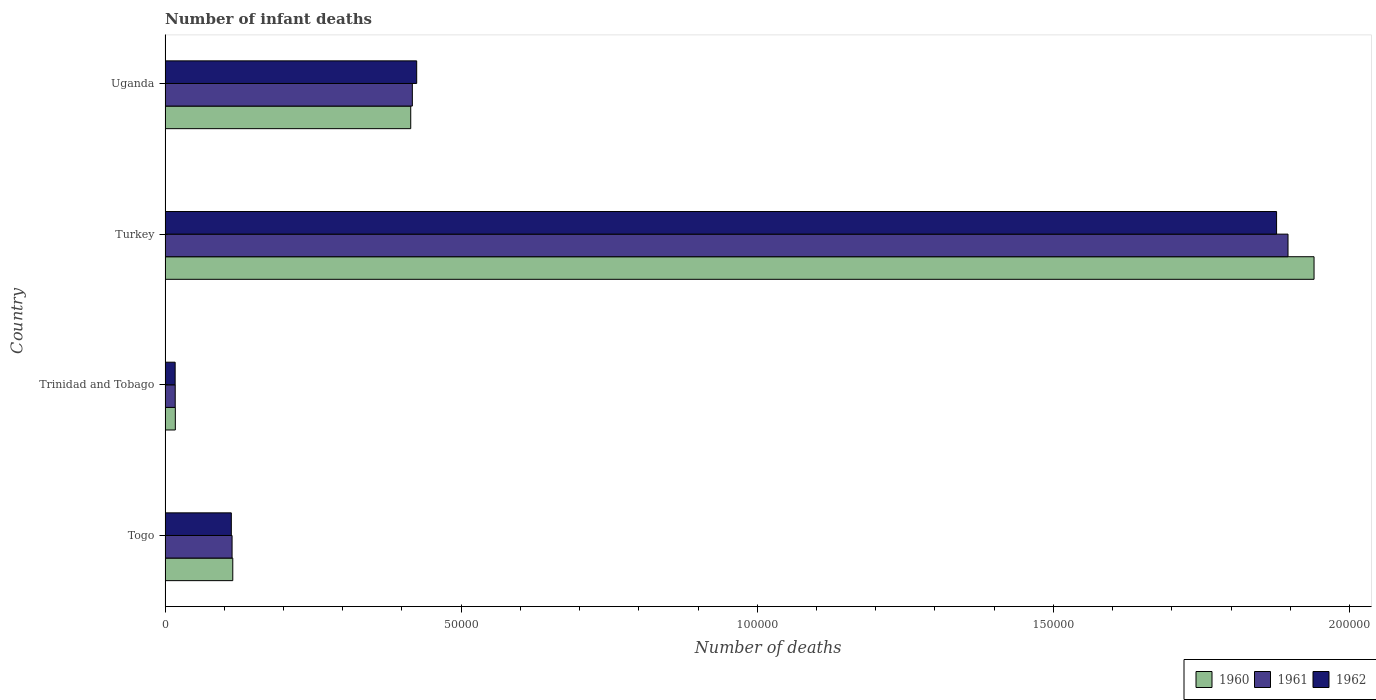How many different coloured bars are there?
Provide a succinct answer. 3. How many groups of bars are there?
Keep it short and to the point. 4. What is the label of the 3rd group of bars from the top?
Provide a succinct answer. Trinidad and Tobago. In how many cases, is the number of bars for a given country not equal to the number of legend labels?
Give a very brief answer. 0. What is the number of infant deaths in 1962 in Uganda?
Give a very brief answer. 4.25e+04. Across all countries, what is the maximum number of infant deaths in 1962?
Offer a very short reply. 1.88e+05. Across all countries, what is the minimum number of infant deaths in 1961?
Offer a very short reply. 1710. In which country was the number of infant deaths in 1961 maximum?
Keep it short and to the point. Turkey. In which country was the number of infant deaths in 1961 minimum?
Keep it short and to the point. Trinidad and Tobago. What is the total number of infant deaths in 1962 in the graph?
Offer a terse response. 2.43e+05. What is the difference between the number of infant deaths in 1961 in Togo and that in Uganda?
Provide a succinct answer. -3.04e+04. What is the difference between the number of infant deaths in 1960 in Uganda and the number of infant deaths in 1961 in Trinidad and Tobago?
Your answer should be very brief. 3.98e+04. What is the average number of infant deaths in 1960 per country?
Make the answer very short. 6.22e+04. What is the difference between the number of infant deaths in 1961 and number of infant deaths in 1962 in Togo?
Give a very brief answer. 126. In how many countries, is the number of infant deaths in 1961 greater than 100000 ?
Provide a succinct answer. 1. What is the ratio of the number of infant deaths in 1962 in Turkey to that in Uganda?
Offer a terse response. 4.42. Is the number of infant deaths in 1961 in Togo less than that in Turkey?
Provide a short and direct response. Yes. Is the difference between the number of infant deaths in 1961 in Togo and Uganda greater than the difference between the number of infant deaths in 1962 in Togo and Uganda?
Your answer should be compact. Yes. What is the difference between the highest and the second highest number of infant deaths in 1962?
Keep it short and to the point. 1.45e+05. What is the difference between the highest and the lowest number of infant deaths in 1962?
Your response must be concise. 1.86e+05. Is the sum of the number of infant deaths in 1960 in Turkey and Uganda greater than the maximum number of infant deaths in 1961 across all countries?
Make the answer very short. Yes. What does the 1st bar from the bottom in Uganda represents?
Give a very brief answer. 1960. Does the graph contain grids?
Make the answer very short. No. What is the title of the graph?
Make the answer very short. Number of infant deaths. Does "1966" appear as one of the legend labels in the graph?
Keep it short and to the point. No. What is the label or title of the X-axis?
Offer a terse response. Number of deaths. What is the Number of deaths of 1960 in Togo?
Provide a succinct answer. 1.14e+04. What is the Number of deaths in 1961 in Togo?
Offer a terse response. 1.13e+04. What is the Number of deaths in 1962 in Togo?
Provide a succinct answer. 1.12e+04. What is the Number of deaths in 1960 in Trinidad and Tobago?
Offer a very short reply. 1728. What is the Number of deaths of 1961 in Trinidad and Tobago?
Give a very brief answer. 1710. What is the Number of deaths of 1962 in Trinidad and Tobago?
Offer a very short reply. 1698. What is the Number of deaths of 1960 in Turkey?
Offer a terse response. 1.94e+05. What is the Number of deaths of 1961 in Turkey?
Your answer should be compact. 1.90e+05. What is the Number of deaths in 1962 in Turkey?
Your answer should be compact. 1.88e+05. What is the Number of deaths in 1960 in Uganda?
Offer a very short reply. 4.15e+04. What is the Number of deaths of 1961 in Uganda?
Offer a very short reply. 4.18e+04. What is the Number of deaths of 1962 in Uganda?
Provide a succinct answer. 4.25e+04. Across all countries, what is the maximum Number of deaths in 1960?
Your response must be concise. 1.94e+05. Across all countries, what is the maximum Number of deaths of 1961?
Give a very brief answer. 1.90e+05. Across all countries, what is the maximum Number of deaths in 1962?
Provide a succinct answer. 1.88e+05. Across all countries, what is the minimum Number of deaths in 1960?
Ensure brevity in your answer.  1728. Across all countries, what is the minimum Number of deaths in 1961?
Provide a short and direct response. 1710. Across all countries, what is the minimum Number of deaths of 1962?
Keep it short and to the point. 1698. What is the total Number of deaths in 1960 in the graph?
Keep it short and to the point. 2.49e+05. What is the total Number of deaths in 1961 in the graph?
Provide a succinct answer. 2.44e+05. What is the total Number of deaths in 1962 in the graph?
Give a very brief answer. 2.43e+05. What is the difference between the Number of deaths of 1960 in Togo and that in Trinidad and Tobago?
Offer a very short reply. 9703. What is the difference between the Number of deaths of 1961 in Togo and that in Trinidad and Tobago?
Provide a short and direct response. 9601. What is the difference between the Number of deaths of 1962 in Togo and that in Trinidad and Tobago?
Your response must be concise. 9487. What is the difference between the Number of deaths of 1960 in Togo and that in Turkey?
Your answer should be compact. -1.83e+05. What is the difference between the Number of deaths of 1961 in Togo and that in Turkey?
Your answer should be compact. -1.78e+05. What is the difference between the Number of deaths in 1962 in Togo and that in Turkey?
Give a very brief answer. -1.77e+05. What is the difference between the Number of deaths of 1960 in Togo and that in Uganda?
Provide a short and direct response. -3.01e+04. What is the difference between the Number of deaths of 1961 in Togo and that in Uganda?
Your response must be concise. -3.04e+04. What is the difference between the Number of deaths in 1962 in Togo and that in Uganda?
Your response must be concise. -3.13e+04. What is the difference between the Number of deaths of 1960 in Trinidad and Tobago and that in Turkey?
Provide a succinct answer. -1.92e+05. What is the difference between the Number of deaths of 1961 in Trinidad and Tobago and that in Turkey?
Offer a very short reply. -1.88e+05. What is the difference between the Number of deaths of 1962 in Trinidad and Tobago and that in Turkey?
Offer a very short reply. -1.86e+05. What is the difference between the Number of deaths of 1960 in Trinidad and Tobago and that in Uganda?
Provide a succinct answer. -3.98e+04. What is the difference between the Number of deaths of 1961 in Trinidad and Tobago and that in Uganda?
Offer a very short reply. -4.00e+04. What is the difference between the Number of deaths in 1962 in Trinidad and Tobago and that in Uganda?
Ensure brevity in your answer.  -4.08e+04. What is the difference between the Number of deaths in 1960 in Turkey and that in Uganda?
Your answer should be compact. 1.53e+05. What is the difference between the Number of deaths in 1961 in Turkey and that in Uganda?
Make the answer very short. 1.48e+05. What is the difference between the Number of deaths of 1962 in Turkey and that in Uganda?
Offer a very short reply. 1.45e+05. What is the difference between the Number of deaths in 1960 in Togo and the Number of deaths in 1961 in Trinidad and Tobago?
Make the answer very short. 9721. What is the difference between the Number of deaths of 1960 in Togo and the Number of deaths of 1962 in Trinidad and Tobago?
Provide a short and direct response. 9733. What is the difference between the Number of deaths in 1961 in Togo and the Number of deaths in 1962 in Trinidad and Tobago?
Ensure brevity in your answer.  9613. What is the difference between the Number of deaths in 1960 in Togo and the Number of deaths in 1961 in Turkey?
Give a very brief answer. -1.78e+05. What is the difference between the Number of deaths in 1960 in Togo and the Number of deaths in 1962 in Turkey?
Keep it short and to the point. -1.76e+05. What is the difference between the Number of deaths of 1961 in Togo and the Number of deaths of 1962 in Turkey?
Offer a terse response. -1.76e+05. What is the difference between the Number of deaths in 1960 in Togo and the Number of deaths in 1961 in Uganda?
Provide a short and direct response. -3.03e+04. What is the difference between the Number of deaths of 1960 in Togo and the Number of deaths of 1962 in Uganda?
Make the answer very short. -3.11e+04. What is the difference between the Number of deaths of 1961 in Togo and the Number of deaths of 1962 in Uganda?
Ensure brevity in your answer.  -3.12e+04. What is the difference between the Number of deaths in 1960 in Trinidad and Tobago and the Number of deaths in 1961 in Turkey?
Your response must be concise. -1.88e+05. What is the difference between the Number of deaths in 1960 in Trinidad and Tobago and the Number of deaths in 1962 in Turkey?
Provide a succinct answer. -1.86e+05. What is the difference between the Number of deaths in 1961 in Trinidad and Tobago and the Number of deaths in 1962 in Turkey?
Your answer should be very brief. -1.86e+05. What is the difference between the Number of deaths of 1960 in Trinidad and Tobago and the Number of deaths of 1961 in Uganda?
Offer a terse response. -4.00e+04. What is the difference between the Number of deaths of 1960 in Trinidad and Tobago and the Number of deaths of 1962 in Uganda?
Your response must be concise. -4.08e+04. What is the difference between the Number of deaths of 1961 in Trinidad and Tobago and the Number of deaths of 1962 in Uganda?
Your response must be concise. -4.08e+04. What is the difference between the Number of deaths of 1960 in Turkey and the Number of deaths of 1961 in Uganda?
Provide a short and direct response. 1.52e+05. What is the difference between the Number of deaths in 1960 in Turkey and the Number of deaths in 1962 in Uganda?
Your answer should be compact. 1.52e+05. What is the difference between the Number of deaths of 1961 in Turkey and the Number of deaths of 1962 in Uganda?
Offer a terse response. 1.47e+05. What is the average Number of deaths of 1960 per country?
Offer a terse response. 6.22e+04. What is the average Number of deaths of 1961 per country?
Your answer should be very brief. 6.11e+04. What is the average Number of deaths of 1962 per country?
Make the answer very short. 6.08e+04. What is the difference between the Number of deaths of 1960 and Number of deaths of 1961 in Togo?
Keep it short and to the point. 120. What is the difference between the Number of deaths of 1960 and Number of deaths of 1962 in Togo?
Provide a short and direct response. 246. What is the difference between the Number of deaths of 1961 and Number of deaths of 1962 in Togo?
Provide a succinct answer. 126. What is the difference between the Number of deaths in 1960 and Number of deaths in 1962 in Trinidad and Tobago?
Your answer should be compact. 30. What is the difference between the Number of deaths of 1961 and Number of deaths of 1962 in Trinidad and Tobago?
Give a very brief answer. 12. What is the difference between the Number of deaths in 1960 and Number of deaths in 1961 in Turkey?
Provide a succinct answer. 4395. What is the difference between the Number of deaths in 1960 and Number of deaths in 1962 in Turkey?
Keep it short and to the point. 6326. What is the difference between the Number of deaths of 1961 and Number of deaths of 1962 in Turkey?
Provide a succinct answer. 1931. What is the difference between the Number of deaths of 1960 and Number of deaths of 1961 in Uganda?
Make the answer very short. -270. What is the difference between the Number of deaths in 1960 and Number of deaths in 1962 in Uganda?
Your response must be concise. -1005. What is the difference between the Number of deaths of 1961 and Number of deaths of 1962 in Uganda?
Keep it short and to the point. -735. What is the ratio of the Number of deaths of 1960 in Togo to that in Trinidad and Tobago?
Make the answer very short. 6.62. What is the ratio of the Number of deaths in 1961 in Togo to that in Trinidad and Tobago?
Your response must be concise. 6.61. What is the ratio of the Number of deaths of 1962 in Togo to that in Trinidad and Tobago?
Ensure brevity in your answer.  6.59. What is the ratio of the Number of deaths in 1960 in Togo to that in Turkey?
Offer a very short reply. 0.06. What is the ratio of the Number of deaths in 1961 in Togo to that in Turkey?
Offer a terse response. 0.06. What is the ratio of the Number of deaths in 1962 in Togo to that in Turkey?
Make the answer very short. 0.06. What is the ratio of the Number of deaths in 1960 in Togo to that in Uganda?
Your answer should be compact. 0.28. What is the ratio of the Number of deaths of 1961 in Togo to that in Uganda?
Ensure brevity in your answer.  0.27. What is the ratio of the Number of deaths in 1962 in Togo to that in Uganda?
Ensure brevity in your answer.  0.26. What is the ratio of the Number of deaths in 1960 in Trinidad and Tobago to that in Turkey?
Offer a terse response. 0.01. What is the ratio of the Number of deaths of 1961 in Trinidad and Tobago to that in Turkey?
Your answer should be very brief. 0.01. What is the ratio of the Number of deaths of 1962 in Trinidad and Tobago to that in Turkey?
Ensure brevity in your answer.  0.01. What is the ratio of the Number of deaths of 1960 in Trinidad and Tobago to that in Uganda?
Offer a terse response. 0.04. What is the ratio of the Number of deaths of 1961 in Trinidad and Tobago to that in Uganda?
Ensure brevity in your answer.  0.04. What is the ratio of the Number of deaths in 1962 in Trinidad and Tobago to that in Uganda?
Keep it short and to the point. 0.04. What is the ratio of the Number of deaths of 1960 in Turkey to that in Uganda?
Ensure brevity in your answer.  4.68. What is the ratio of the Number of deaths of 1961 in Turkey to that in Uganda?
Your response must be concise. 4.54. What is the ratio of the Number of deaths in 1962 in Turkey to that in Uganda?
Your answer should be compact. 4.42. What is the difference between the highest and the second highest Number of deaths of 1960?
Offer a terse response. 1.53e+05. What is the difference between the highest and the second highest Number of deaths in 1961?
Your answer should be very brief. 1.48e+05. What is the difference between the highest and the second highest Number of deaths in 1962?
Your answer should be compact. 1.45e+05. What is the difference between the highest and the lowest Number of deaths in 1960?
Your answer should be very brief. 1.92e+05. What is the difference between the highest and the lowest Number of deaths in 1961?
Offer a terse response. 1.88e+05. What is the difference between the highest and the lowest Number of deaths of 1962?
Provide a succinct answer. 1.86e+05. 